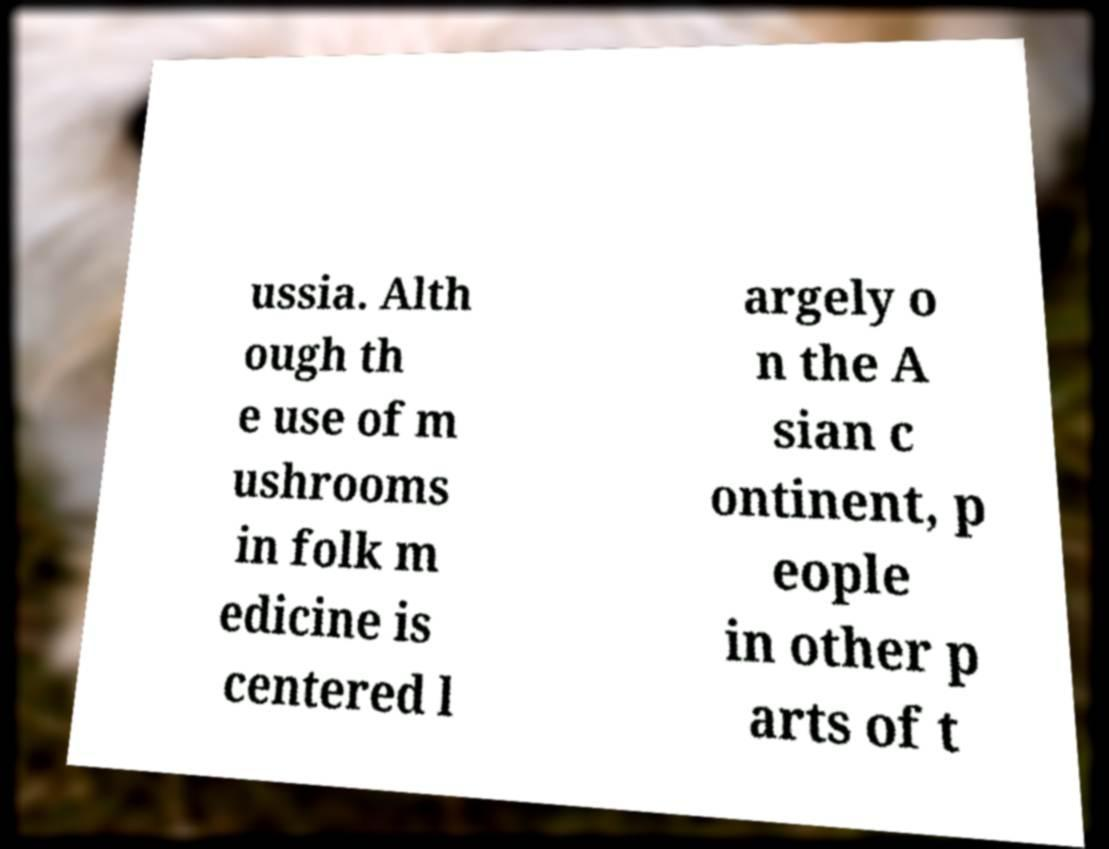Can you read and provide the text displayed in the image?This photo seems to have some interesting text. Can you extract and type it out for me? ussia. Alth ough th e use of m ushrooms in folk m edicine is centered l argely o n the A sian c ontinent, p eople in other p arts of t 